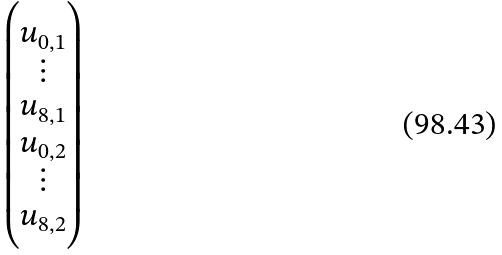Convert formula to latex. <formula><loc_0><loc_0><loc_500><loc_500>\begin{pmatrix} u _ { 0 , 1 } \\ \vdots \\ u _ { 8 , 1 } \\ u _ { 0 , 2 } \\ \vdots \\ u _ { 8 , 2 } \end{pmatrix}</formula> 